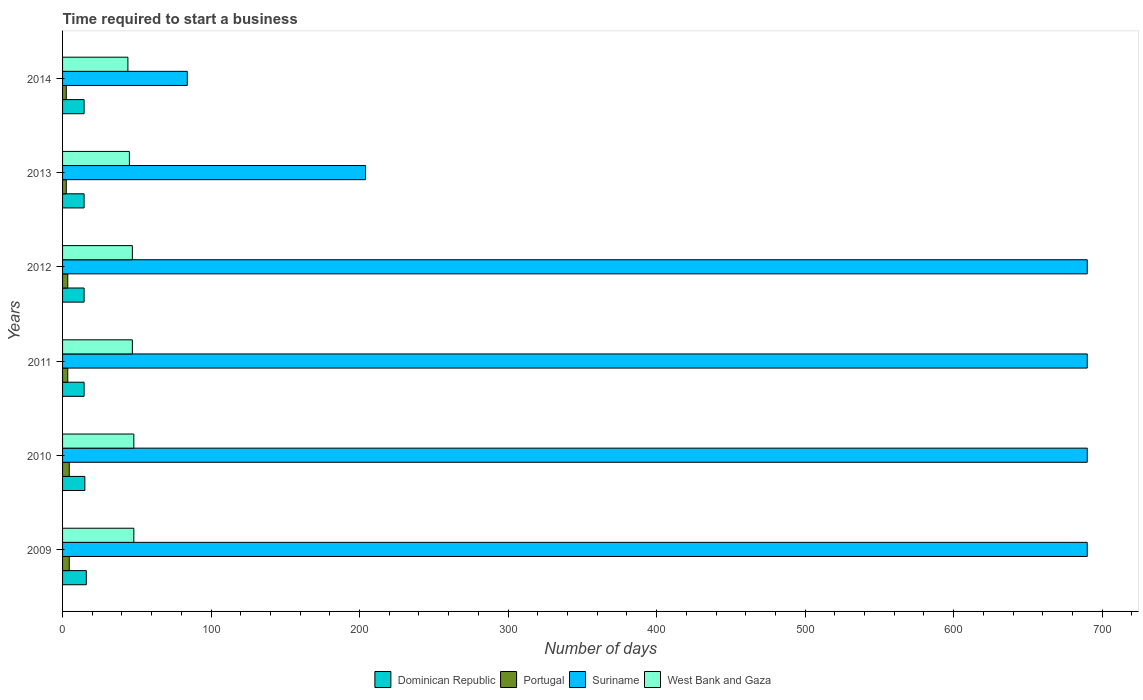How many different coloured bars are there?
Your response must be concise. 4. Are the number of bars per tick equal to the number of legend labels?
Ensure brevity in your answer.  Yes. How many bars are there on the 3rd tick from the top?
Give a very brief answer. 4. In how many cases, is the number of bars for a given year not equal to the number of legend labels?
Keep it short and to the point. 0. What is the number of days required to start a business in Dominican Republic in 2011?
Your response must be concise. 14.5. Across all years, what is the maximum number of days required to start a business in Portugal?
Your answer should be very brief. 4.5. In which year was the number of days required to start a business in Suriname maximum?
Ensure brevity in your answer.  2009. What is the difference between the number of days required to start a business in West Bank and Gaza in 2009 and the number of days required to start a business in Dominican Republic in 2014?
Ensure brevity in your answer.  33.5. What is the average number of days required to start a business in West Bank and Gaza per year?
Provide a succinct answer. 46.5. In the year 2010, what is the difference between the number of days required to start a business in Suriname and number of days required to start a business in West Bank and Gaza?
Keep it short and to the point. 642. What is the ratio of the number of days required to start a business in Dominican Republic in 2009 to that in 2014?
Provide a short and direct response. 1.1. What is the difference between the highest and the second highest number of days required to start a business in Portugal?
Your response must be concise. 0. What is the difference between the highest and the lowest number of days required to start a business in West Bank and Gaza?
Offer a terse response. 4. Is the sum of the number of days required to start a business in Portugal in 2009 and 2012 greater than the maximum number of days required to start a business in West Bank and Gaza across all years?
Your response must be concise. No. Is it the case that in every year, the sum of the number of days required to start a business in Suriname and number of days required to start a business in Dominican Republic is greater than the sum of number of days required to start a business in West Bank and Gaza and number of days required to start a business in Portugal?
Give a very brief answer. Yes. What does the 4th bar from the top in 2013 represents?
Your answer should be compact. Dominican Republic. What is the difference between two consecutive major ticks on the X-axis?
Offer a terse response. 100. Where does the legend appear in the graph?
Make the answer very short. Bottom center. What is the title of the graph?
Keep it short and to the point. Time required to start a business. Does "Bosnia and Herzegovina" appear as one of the legend labels in the graph?
Make the answer very short. No. What is the label or title of the X-axis?
Provide a succinct answer. Number of days. What is the label or title of the Y-axis?
Give a very brief answer. Years. What is the Number of days in Dominican Republic in 2009?
Give a very brief answer. 16. What is the Number of days of Suriname in 2009?
Provide a succinct answer. 690. What is the Number of days of West Bank and Gaza in 2009?
Offer a very short reply. 48. What is the Number of days of Portugal in 2010?
Your answer should be compact. 4.5. What is the Number of days in Suriname in 2010?
Offer a very short reply. 690. What is the Number of days of Dominican Republic in 2011?
Your answer should be very brief. 14.5. What is the Number of days of Suriname in 2011?
Make the answer very short. 690. What is the Number of days of West Bank and Gaza in 2011?
Make the answer very short. 47. What is the Number of days in Portugal in 2012?
Give a very brief answer. 3.5. What is the Number of days of Suriname in 2012?
Make the answer very short. 690. What is the Number of days of West Bank and Gaza in 2012?
Give a very brief answer. 47. What is the Number of days of Suriname in 2013?
Your answer should be compact. 204. What is the Number of days of Dominican Republic in 2014?
Give a very brief answer. 14.5. What is the Number of days in Portugal in 2014?
Make the answer very short. 2.5. What is the Number of days in Suriname in 2014?
Your response must be concise. 84. Across all years, what is the maximum Number of days in Dominican Republic?
Offer a terse response. 16. Across all years, what is the maximum Number of days in Suriname?
Make the answer very short. 690. Across all years, what is the minimum Number of days of Suriname?
Your answer should be compact. 84. Across all years, what is the minimum Number of days of West Bank and Gaza?
Ensure brevity in your answer.  44. What is the total Number of days of Dominican Republic in the graph?
Make the answer very short. 89. What is the total Number of days in Portugal in the graph?
Offer a terse response. 21. What is the total Number of days of Suriname in the graph?
Offer a terse response. 3048. What is the total Number of days in West Bank and Gaza in the graph?
Make the answer very short. 279. What is the difference between the Number of days of Portugal in 2009 and that in 2010?
Provide a succinct answer. 0. What is the difference between the Number of days in Suriname in 2009 and that in 2010?
Keep it short and to the point. 0. What is the difference between the Number of days of Portugal in 2009 and that in 2011?
Make the answer very short. 1. What is the difference between the Number of days in West Bank and Gaza in 2009 and that in 2011?
Make the answer very short. 1. What is the difference between the Number of days in Suriname in 2009 and that in 2012?
Ensure brevity in your answer.  0. What is the difference between the Number of days of West Bank and Gaza in 2009 and that in 2012?
Offer a very short reply. 1. What is the difference between the Number of days in Portugal in 2009 and that in 2013?
Provide a short and direct response. 2. What is the difference between the Number of days in Suriname in 2009 and that in 2013?
Your answer should be compact. 486. What is the difference between the Number of days in West Bank and Gaza in 2009 and that in 2013?
Your answer should be compact. 3. What is the difference between the Number of days of Dominican Republic in 2009 and that in 2014?
Your answer should be very brief. 1.5. What is the difference between the Number of days in Suriname in 2009 and that in 2014?
Make the answer very short. 606. What is the difference between the Number of days in West Bank and Gaza in 2009 and that in 2014?
Provide a succinct answer. 4. What is the difference between the Number of days of Portugal in 2010 and that in 2011?
Offer a terse response. 1. What is the difference between the Number of days of Portugal in 2010 and that in 2012?
Offer a terse response. 1. What is the difference between the Number of days of West Bank and Gaza in 2010 and that in 2012?
Your answer should be very brief. 1. What is the difference between the Number of days of Dominican Republic in 2010 and that in 2013?
Your response must be concise. 0.5. What is the difference between the Number of days of Suriname in 2010 and that in 2013?
Provide a succinct answer. 486. What is the difference between the Number of days of West Bank and Gaza in 2010 and that in 2013?
Your answer should be compact. 3. What is the difference between the Number of days in Suriname in 2010 and that in 2014?
Ensure brevity in your answer.  606. What is the difference between the Number of days of West Bank and Gaza in 2010 and that in 2014?
Your response must be concise. 4. What is the difference between the Number of days of Portugal in 2011 and that in 2012?
Your answer should be very brief. 0. What is the difference between the Number of days of Suriname in 2011 and that in 2012?
Make the answer very short. 0. What is the difference between the Number of days of West Bank and Gaza in 2011 and that in 2012?
Give a very brief answer. 0. What is the difference between the Number of days of Dominican Republic in 2011 and that in 2013?
Provide a short and direct response. 0. What is the difference between the Number of days in Suriname in 2011 and that in 2013?
Your response must be concise. 486. What is the difference between the Number of days of Dominican Republic in 2011 and that in 2014?
Provide a short and direct response. 0. What is the difference between the Number of days of Portugal in 2011 and that in 2014?
Your response must be concise. 1. What is the difference between the Number of days of Suriname in 2011 and that in 2014?
Your answer should be compact. 606. What is the difference between the Number of days of West Bank and Gaza in 2011 and that in 2014?
Your answer should be compact. 3. What is the difference between the Number of days in Dominican Republic in 2012 and that in 2013?
Keep it short and to the point. 0. What is the difference between the Number of days in Portugal in 2012 and that in 2013?
Your answer should be compact. 1. What is the difference between the Number of days of Suriname in 2012 and that in 2013?
Your answer should be compact. 486. What is the difference between the Number of days in Dominican Republic in 2012 and that in 2014?
Your answer should be compact. 0. What is the difference between the Number of days in Portugal in 2012 and that in 2014?
Keep it short and to the point. 1. What is the difference between the Number of days of Suriname in 2012 and that in 2014?
Keep it short and to the point. 606. What is the difference between the Number of days of Portugal in 2013 and that in 2014?
Ensure brevity in your answer.  0. What is the difference between the Number of days in Suriname in 2013 and that in 2014?
Provide a short and direct response. 120. What is the difference between the Number of days in West Bank and Gaza in 2013 and that in 2014?
Provide a short and direct response. 1. What is the difference between the Number of days of Dominican Republic in 2009 and the Number of days of Suriname in 2010?
Ensure brevity in your answer.  -674. What is the difference between the Number of days in Dominican Republic in 2009 and the Number of days in West Bank and Gaza in 2010?
Provide a succinct answer. -32. What is the difference between the Number of days of Portugal in 2009 and the Number of days of Suriname in 2010?
Make the answer very short. -685.5. What is the difference between the Number of days of Portugal in 2009 and the Number of days of West Bank and Gaza in 2010?
Make the answer very short. -43.5. What is the difference between the Number of days in Suriname in 2009 and the Number of days in West Bank and Gaza in 2010?
Offer a terse response. 642. What is the difference between the Number of days of Dominican Republic in 2009 and the Number of days of Suriname in 2011?
Your answer should be compact. -674. What is the difference between the Number of days of Dominican Republic in 2009 and the Number of days of West Bank and Gaza in 2011?
Give a very brief answer. -31. What is the difference between the Number of days in Portugal in 2009 and the Number of days in Suriname in 2011?
Give a very brief answer. -685.5. What is the difference between the Number of days in Portugal in 2009 and the Number of days in West Bank and Gaza in 2011?
Keep it short and to the point. -42.5. What is the difference between the Number of days of Suriname in 2009 and the Number of days of West Bank and Gaza in 2011?
Make the answer very short. 643. What is the difference between the Number of days of Dominican Republic in 2009 and the Number of days of Portugal in 2012?
Give a very brief answer. 12.5. What is the difference between the Number of days in Dominican Republic in 2009 and the Number of days in Suriname in 2012?
Your answer should be compact. -674. What is the difference between the Number of days of Dominican Republic in 2009 and the Number of days of West Bank and Gaza in 2012?
Your answer should be compact. -31. What is the difference between the Number of days of Portugal in 2009 and the Number of days of Suriname in 2012?
Your answer should be very brief. -685.5. What is the difference between the Number of days of Portugal in 2009 and the Number of days of West Bank and Gaza in 2012?
Provide a short and direct response. -42.5. What is the difference between the Number of days of Suriname in 2009 and the Number of days of West Bank and Gaza in 2012?
Your response must be concise. 643. What is the difference between the Number of days in Dominican Republic in 2009 and the Number of days in Portugal in 2013?
Give a very brief answer. 13.5. What is the difference between the Number of days in Dominican Republic in 2009 and the Number of days in Suriname in 2013?
Make the answer very short. -188. What is the difference between the Number of days of Dominican Republic in 2009 and the Number of days of West Bank and Gaza in 2013?
Your answer should be compact. -29. What is the difference between the Number of days in Portugal in 2009 and the Number of days in Suriname in 2013?
Provide a succinct answer. -199.5. What is the difference between the Number of days in Portugal in 2009 and the Number of days in West Bank and Gaza in 2013?
Make the answer very short. -40.5. What is the difference between the Number of days of Suriname in 2009 and the Number of days of West Bank and Gaza in 2013?
Ensure brevity in your answer.  645. What is the difference between the Number of days of Dominican Republic in 2009 and the Number of days of Portugal in 2014?
Keep it short and to the point. 13.5. What is the difference between the Number of days of Dominican Republic in 2009 and the Number of days of Suriname in 2014?
Make the answer very short. -68. What is the difference between the Number of days in Dominican Republic in 2009 and the Number of days in West Bank and Gaza in 2014?
Provide a succinct answer. -28. What is the difference between the Number of days in Portugal in 2009 and the Number of days in Suriname in 2014?
Make the answer very short. -79.5. What is the difference between the Number of days of Portugal in 2009 and the Number of days of West Bank and Gaza in 2014?
Make the answer very short. -39.5. What is the difference between the Number of days of Suriname in 2009 and the Number of days of West Bank and Gaza in 2014?
Make the answer very short. 646. What is the difference between the Number of days of Dominican Republic in 2010 and the Number of days of Suriname in 2011?
Offer a terse response. -675. What is the difference between the Number of days in Dominican Republic in 2010 and the Number of days in West Bank and Gaza in 2011?
Offer a very short reply. -32. What is the difference between the Number of days of Portugal in 2010 and the Number of days of Suriname in 2011?
Your answer should be compact. -685.5. What is the difference between the Number of days in Portugal in 2010 and the Number of days in West Bank and Gaza in 2011?
Offer a terse response. -42.5. What is the difference between the Number of days of Suriname in 2010 and the Number of days of West Bank and Gaza in 2011?
Provide a succinct answer. 643. What is the difference between the Number of days of Dominican Republic in 2010 and the Number of days of Portugal in 2012?
Offer a terse response. 11.5. What is the difference between the Number of days of Dominican Republic in 2010 and the Number of days of Suriname in 2012?
Your answer should be very brief. -675. What is the difference between the Number of days in Dominican Republic in 2010 and the Number of days in West Bank and Gaza in 2012?
Provide a succinct answer. -32. What is the difference between the Number of days of Portugal in 2010 and the Number of days of Suriname in 2012?
Your response must be concise. -685.5. What is the difference between the Number of days in Portugal in 2010 and the Number of days in West Bank and Gaza in 2012?
Your response must be concise. -42.5. What is the difference between the Number of days in Suriname in 2010 and the Number of days in West Bank and Gaza in 2012?
Ensure brevity in your answer.  643. What is the difference between the Number of days in Dominican Republic in 2010 and the Number of days in Portugal in 2013?
Keep it short and to the point. 12.5. What is the difference between the Number of days of Dominican Republic in 2010 and the Number of days of Suriname in 2013?
Your response must be concise. -189. What is the difference between the Number of days of Portugal in 2010 and the Number of days of Suriname in 2013?
Offer a very short reply. -199.5. What is the difference between the Number of days in Portugal in 2010 and the Number of days in West Bank and Gaza in 2013?
Offer a terse response. -40.5. What is the difference between the Number of days of Suriname in 2010 and the Number of days of West Bank and Gaza in 2013?
Your response must be concise. 645. What is the difference between the Number of days in Dominican Republic in 2010 and the Number of days in Portugal in 2014?
Offer a terse response. 12.5. What is the difference between the Number of days in Dominican Republic in 2010 and the Number of days in Suriname in 2014?
Offer a very short reply. -69. What is the difference between the Number of days of Portugal in 2010 and the Number of days of Suriname in 2014?
Provide a short and direct response. -79.5. What is the difference between the Number of days in Portugal in 2010 and the Number of days in West Bank and Gaza in 2014?
Keep it short and to the point. -39.5. What is the difference between the Number of days of Suriname in 2010 and the Number of days of West Bank and Gaza in 2014?
Make the answer very short. 646. What is the difference between the Number of days in Dominican Republic in 2011 and the Number of days in Portugal in 2012?
Give a very brief answer. 11. What is the difference between the Number of days in Dominican Republic in 2011 and the Number of days in Suriname in 2012?
Provide a succinct answer. -675.5. What is the difference between the Number of days of Dominican Republic in 2011 and the Number of days of West Bank and Gaza in 2012?
Your answer should be very brief. -32.5. What is the difference between the Number of days of Portugal in 2011 and the Number of days of Suriname in 2012?
Ensure brevity in your answer.  -686.5. What is the difference between the Number of days of Portugal in 2011 and the Number of days of West Bank and Gaza in 2012?
Offer a very short reply. -43.5. What is the difference between the Number of days in Suriname in 2011 and the Number of days in West Bank and Gaza in 2012?
Offer a terse response. 643. What is the difference between the Number of days in Dominican Republic in 2011 and the Number of days in Portugal in 2013?
Your response must be concise. 12. What is the difference between the Number of days in Dominican Republic in 2011 and the Number of days in Suriname in 2013?
Your answer should be very brief. -189.5. What is the difference between the Number of days in Dominican Republic in 2011 and the Number of days in West Bank and Gaza in 2013?
Provide a short and direct response. -30.5. What is the difference between the Number of days of Portugal in 2011 and the Number of days of Suriname in 2013?
Keep it short and to the point. -200.5. What is the difference between the Number of days in Portugal in 2011 and the Number of days in West Bank and Gaza in 2013?
Provide a succinct answer. -41.5. What is the difference between the Number of days of Suriname in 2011 and the Number of days of West Bank and Gaza in 2013?
Your answer should be very brief. 645. What is the difference between the Number of days of Dominican Republic in 2011 and the Number of days of Portugal in 2014?
Your response must be concise. 12. What is the difference between the Number of days in Dominican Republic in 2011 and the Number of days in Suriname in 2014?
Offer a very short reply. -69.5. What is the difference between the Number of days of Dominican Republic in 2011 and the Number of days of West Bank and Gaza in 2014?
Offer a terse response. -29.5. What is the difference between the Number of days of Portugal in 2011 and the Number of days of Suriname in 2014?
Keep it short and to the point. -80.5. What is the difference between the Number of days in Portugal in 2011 and the Number of days in West Bank and Gaza in 2014?
Provide a succinct answer. -40.5. What is the difference between the Number of days of Suriname in 2011 and the Number of days of West Bank and Gaza in 2014?
Provide a short and direct response. 646. What is the difference between the Number of days of Dominican Republic in 2012 and the Number of days of Portugal in 2013?
Ensure brevity in your answer.  12. What is the difference between the Number of days of Dominican Republic in 2012 and the Number of days of Suriname in 2013?
Offer a very short reply. -189.5. What is the difference between the Number of days of Dominican Republic in 2012 and the Number of days of West Bank and Gaza in 2013?
Your answer should be very brief. -30.5. What is the difference between the Number of days in Portugal in 2012 and the Number of days in Suriname in 2013?
Give a very brief answer. -200.5. What is the difference between the Number of days in Portugal in 2012 and the Number of days in West Bank and Gaza in 2013?
Make the answer very short. -41.5. What is the difference between the Number of days of Suriname in 2012 and the Number of days of West Bank and Gaza in 2013?
Your answer should be compact. 645. What is the difference between the Number of days of Dominican Republic in 2012 and the Number of days of Portugal in 2014?
Your response must be concise. 12. What is the difference between the Number of days of Dominican Republic in 2012 and the Number of days of Suriname in 2014?
Make the answer very short. -69.5. What is the difference between the Number of days of Dominican Republic in 2012 and the Number of days of West Bank and Gaza in 2014?
Make the answer very short. -29.5. What is the difference between the Number of days of Portugal in 2012 and the Number of days of Suriname in 2014?
Provide a succinct answer. -80.5. What is the difference between the Number of days of Portugal in 2012 and the Number of days of West Bank and Gaza in 2014?
Your answer should be very brief. -40.5. What is the difference between the Number of days in Suriname in 2012 and the Number of days in West Bank and Gaza in 2014?
Provide a succinct answer. 646. What is the difference between the Number of days in Dominican Republic in 2013 and the Number of days in Portugal in 2014?
Make the answer very short. 12. What is the difference between the Number of days in Dominican Republic in 2013 and the Number of days in Suriname in 2014?
Make the answer very short. -69.5. What is the difference between the Number of days of Dominican Republic in 2013 and the Number of days of West Bank and Gaza in 2014?
Make the answer very short. -29.5. What is the difference between the Number of days of Portugal in 2013 and the Number of days of Suriname in 2014?
Provide a short and direct response. -81.5. What is the difference between the Number of days of Portugal in 2013 and the Number of days of West Bank and Gaza in 2014?
Ensure brevity in your answer.  -41.5. What is the difference between the Number of days in Suriname in 2013 and the Number of days in West Bank and Gaza in 2014?
Provide a succinct answer. 160. What is the average Number of days of Dominican Republic per year?
Your answer should be compact. 14.83. What is the average Number of days in Suriname per year?
Offer a very short reply. 508. What is the average Number of days in West Bank and Gaza per year?
Your response must be concise. 46.5. In the year 2009, what is the difference between the Number of days of Dominican Republic and Number of days of Suriname?
Make the answer very short. -674. In the year 2009, what is the difference between the Number of days of Dominican Republic and Number of days of West Bank and Gaza?
Give a very brief answer. -32. In the year 2009, what is the difference between the Number of days of Portugal and Number of days of Suriname?
Ensure brevity in your answer.  -685.5. In the year 2009, what is the difference between the Number of days in Portugal and Number of days in West Bank and Gaza?
Ensure brevity in your answer.  -43.5. In the year 2009, what is the difference between the Number of days in Suriname and Number of days in West Bank and Gaza?
Your response must be concise. 642. In the year 2010, what is the difference between the Number of days in Dominican Republic and Number of days in Suriname?
Offer a very short reply. -675. In the year 2010, what is the difference between the Number of days in Dominican Republic and Number of days in West Bank and Gaza?
Keep it short and to the point. -33. In the year 2010, what is the difference between the Number of days of Portugal and Number of days of Suriname?
Give a very brief answer. -685.5. In the year 2010, what is the difference between the Number of days of Portugal and Number of days of West Bank and Gaza?
Your answer should be very brief. -43.5. In the year 2010, what is the difference between the Number of days in Suriname and Number of days in West Bank and Gaza?
Offer a terse response. 642. In the year 2011, what is the difference between the Number of days in Dominican Republic and Number of days in Portugal?
Your answer should be compact. 11. In the year 2011, what is the difference between the Number of days in Dominican Republic and Number of days in Suriname?
Your answer should be compact. -675.5. In the year 2011, what is the difference between the Number of days of Dominican Republic and Number of days of West Bank and Gaza?
Keep it short and to the point. -32.5. In the year 2011, what is the difference between the Number of days of Portugal and Number of days of Suriname?
Offer a very short reply. -686.5. In the year 2011, what is the difference between the Number of days in Portugal and Number of days in West Bank and Gaza?
Provide a succinct answer. -43.5. In the year 2011, what is the difference between the Number of days of Suriname and Number of days of West Bank and Gaza?
Offer a very short reply. 643. In the year 2012, what is the difference between the Number of days of Dominican Republic and Number of days of Suriname?
Your answer should be very brief. -675.5. In the year 2012, what is the difference between the Number of days in Dominican Republic and Number of days in West Bank and Gaza?
Offer a very short reply. -32.5. In the year 2012, what is the difference between the Number of days of Portugal and Number of days of Suriname?
Your answer should be very brief. -686.5. In the year 2012, what is the difference between the Number of days in Portugal and Number of days in West Bank and Gaza?
Make the answer very short. -43.5. In the year 2012, what is the difference between the Number of days of Suriname and Number of days of West Bank and Gaza?
Your answer should be compact. 643. In the year 2013, what is the difference between the Number of days of Dominican Republic and Number of days of Suriname?
Keep it short and to the point. -189.5. In the year 2013, what is the difference between the Number of days of Dominican Republic and Number of days of West Bank and Gaza?
Make the answer very short. -30.5. In the year 2013, what is the difference between the Number of days in Portugal and Number of days in Suriname?
Provide a short and direct response. -201.5. In the year 2013, what is the difference between the Number of days in Portugal and Number of days in West Bank and Gaza?
Offer a very short reply. -42.5. In the year 2013, what is the difference between the Number of days of Suriname and Number of days of West Bank and Gaza?
Offer a very short reply. 159. In the year 2014, what is the difference between the Number of days of Dominican Republic and Number of days of Suriname?
Ensure brevity in your answer.  -69.5. In the year 2014, what is the difference between the Number of days in Dominican Republic and Number of days in West Bank and Gaza?
Make the answer very short. -29.5. In the year 2014, what is the difference between the Number of days in Portugal and Number of days in Suriname?
Offer a very short reply. -81.5. In the year 2014, what is the difference between the Number of days of Portugal and Number of days of West Bank and Gaza?
Offer a very short reply. -41.5. What is the ratio of the Number of days in Dominican Republic in 2009 to that in 2010?
Provide a short and direct response. 1.07. What is the ratio of the Number of days of Suriname in 2009 to that in 2010?
Make the answer very short. 1. What is the ratio of the Number of days in West Bank and Gaza in 2009 to that in 2010?
Give a very brief answer. 1. What is the ratio of the Number of days of Dominican Republic in 2009 to that in 2011?
Your answer should be very brief. 1.1. What is the ratio of the Number of days of Suriname in 2009 to that in 2011?
Offer a terse response. 1. What is the ratio of the Number of days in West Bank and Gaza in 2009 to that in 2011?
Provide a succinct answer. 1.02. What is the ratio of the Number of days of Dominican Republic in 2009 to that in 2012?
Keep it short and to the point. 1.1. What is the ratio of the Number of days of West Bank and Gaza in 2009 to that in 2012?
Your answer should be compact. 1.02. What is the ratio of the Number of days of Dominican Republic in 2009 to that in 2013?
Keep it short and to the point. 1.1. What is the ratio of the Number of days in Portugal in 2009 to that in 2013?
Give a very brief answer. 1.8. What is the ratio of the Number of days of Suriname in 2009 to that in 2013?
Ensure brevity in your answer.  3.38. What is the ratio of the Number of days in West Bank and Gaza in 2009 to that in 2013?
Offer a terse response. 1.07. What is the ratio of the Number of days in Dominican Republic in 2009 to that in 2014?
Ensure brevity in your answer.  1.1. What is the ratio of the Number of days of Suriname in 2009 to that in 2014?
Your answer should be very brief. 8.21. What is the ratio of the Number of days in Dominican Republic in 2010 to that in 2011?
Make the answer very short. 1.03. What is the ratio of the Number of days in West Bank and Gaza in 2010 to that in 2011?
Give a very brief answer. 1.02. What is the ratio of the Number of days of Dominican Republic in 2010 to that in 2012?
Offer a terse response. 1.03. What is the ratio of the Number of days of Portugal in 2010 to that in 2012?
Your answer should be very brief. 1.29. What is the ratio of the Number of days in West Bank and Gaza in 2010 to that in 2012?
Make the answer very short. 1.02. What is the ratio of the Number of days in Dominican Republic in 2010 to that in 2013?
Ensure brevity in your answer.  1.03. What is the ratio of the Number of days of Portugal in 2010 to that in 2013?
Your answer should be compact. 1.8. What is the ratio of the Number of days of Suriname in 2010 to that in 2013?
Offer a terse response. 3.38. What is the ratio of the Number of days in West Bank and Gaza in 2010 to that in 2013?
Your answer should be compact. 1.07. What is the ratio of the Number of days in Dominican Republic in 2010 to that in 2014?
Make the answer very short. 1.03. What is the ratio of the Number of days in Suriname in 2010 to that in 2014?
Offer a terse response. 8.21. What is the ratio of the Number of days in Dominican Republic in 2011 to that in 2012?
Offer a very short reply. 1. What is the ratio of the Number of days in Suriname in 2011 to that in 2012?
Your answer should be compact. 1. What is the ratio of the Number of days in Dominican Republic in 2011 to that in 2013?
Ensure brevity in your answer.  1. What is the ratio of the Number of days of Suriname in 2011 to that in 2013?
Give a very brief answer. 3.38. What is the ratio of the Number of days of West Bank and Gaza in 2011 to that in 2013?
Offer a terse response. 1.04. What is the ratio of the Number of days of Dominican Republic in 2011 to that in 2014?
Offer a terse response. 1. What is the ratio of the Number of days of Portugal in 2011 to that in 2014?
Your answer should be compact. 1.4. What is the ratio of the Number of days in Suriname in 2011 to that in 2014?
Give a very brief answer. 8.21. What is the ratio of the Number of days of West Bank and Gaza in 2011 to that in 2014?
Make the answer very short. 1.07. What is the ratio of the Number of days of Dominican Republic in 2012 to that in 2013?
Your response must be concise. 1. What is the ratio of the Number of days of Portugal in 2012 to that in 2013?
Your answer should be compact. 1.4. What is the ratio of the Number of days of Suriname in 2012 to that in 2013?
Keep it short and to the point. 3.38. What is the ratio of the Number of days in West Bank and Gaza in 2012 to that in 2013?
Your answer should be very brief. 1.04. What is the ratio of the Number of days in Dominican Republic in 2012 to that in 2014?
Your answer should be very brief. 1. What is the ratio of the Number of days of Suriname in 2012 to that in 2014?
Make the answer very short. 8.21. What is the ratio of the Number of days in West Bank and Gaza in 2012 to that in 2014?
Your answer should be very brief. 1.07. What is the ratio of the Number of days of Portugal in 2013 to that in 2014?
Offer a terse response. 1. What is the ratio of the Number of days in Suriname in 2013 to that in 2014?
Provide a succinct answer. 2.43. What is the ratio of the Number of days of West Bank and Gaza in 2013 to that in 2014?
Your answer should be very brief. 1.02. What is the difference between the highest and the second highest Number of days of Portugal?
Keep it short and to the point. 0. What is the difference between the highest and the second highest Number of days in Suriname?
Your answer should be very brief. 0. What is the difference between the highest and the second highest Number of days in West Bank and Gaza?
Offer a terse response. 0. What is the difference between the highest and the lowest Number of days in Dominican Republic?
Provide a short and direct response. 1.5. What is the difference between the highest and the lowest Number of days of Portugal?
Keep it short and to the point. 2. What is the difference between the highest and the lowest Number of days of Suriname?
Provide a short and direct response. 606. What is the difference between the highest and the lowest Number of days in West Bank and Gaza?
Ensure brevity in your answer.  4. 